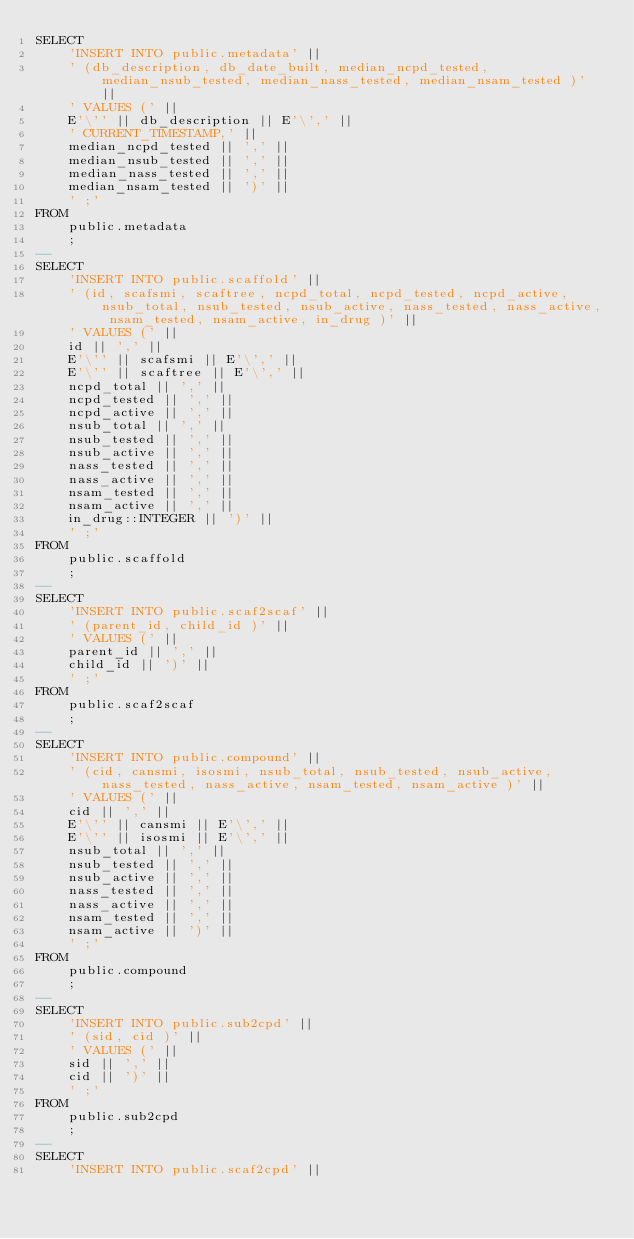Convert code to text. <code><loc_0><loc_0><loc_500><loc_500><_SQL_>SELECT
	'INSERT INTO public.metadata' ||
	' (db_description, db_date_built, median_ncpd_tested, median_nsub_tested, median_nass_tested, median_nsam_tested )' ||
	' VALUES (' ||
	E'\'' || db_description || E'\',' ||
	' CURRENT_TIMESTAMP,' ||
	median_ncpd_tested || ',' ||
	median_nsub_tested || ',' ||
	median_nass_tested || ',' ||
	median_nsam_tested || ')' ||
	' ;'
FROM
	public.metadata
	;
--
SELECT
	'INSERT INTO public.scaffold' ||
	' (id, scafsmi, scaftree, ncpd_total, ncpd_tested, ncpd_active, nsub_total, nsub_tested, nsub_active, nass_tested, nass_active, nsam_tested, nsam_active, in_drug )' ||
	' VALUES (' ||
	id || ',' ||
	E'\'' || scafsmi || E'\',' ||
	E'\'' || scaftree || E'\',' ||
	ncpd_total || ',' ||
	ncpd_tested || ',' ||
	ncpd_active || ',' ||
	nsub_total || ',' ||
	nsub_tested || ',' ||
	nsub_active || ',' ||
	nass_tested || ',' ||
	nass_active || ',' ||
	nsam_tested || ',' ||
	nsam_active || ',' ||
	in_drug::INTEGER || ')' ||
	' ;'
FROM
	public.scaffold
	;
--
SELECT
	'INSERT INTO public.scaf2scaf' ||
	' (parent_id, child_id )' ||
	' VALUES (' ||
	parent_id || ',' ||
	child_id || ')' ||
	' ;'
FROM
	public.scaf2scaf
	;
--
SELECT
	'INSERT INTO public.compound' ||
	' (cid, cansmi, isosmi, nsub_total, nsub_tested, nsub_active, nass_tested, nass_active, nsam_tested, nsam_active )' ||
	' VALUES (' ||
	cid || ',' ||
	E'\'' || cansmi || E'\',' ||
	E'\'' || isosmi || E'\',' ||
	nsub_total || ',' ||
	nsub_tested || ',' ||
	nsub_active || ',' ||
	nass_tested || ',' ||
	nass_active || ',' ||
	nsam_tested || ',' ||
	nsam_active || ')' ||
	' ;'
FROM
	public.compound
	;
--
SELECT
	'INSERT INTO public.sub2cpd' ||
	' (sid, cid )' ||
	' VALUES (' ||
	sid || ',' ||
	cid || ')' ||
	' ;'
FROM
	public.sub2cpd
	;
--
SELECT
	'INSERT INTO public.scaf2cpd' ||</code> 